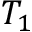Convert formula to latex. <formula><loc_0><loc_0><loc_500><loc_500>T _ { 1 }</formula> 